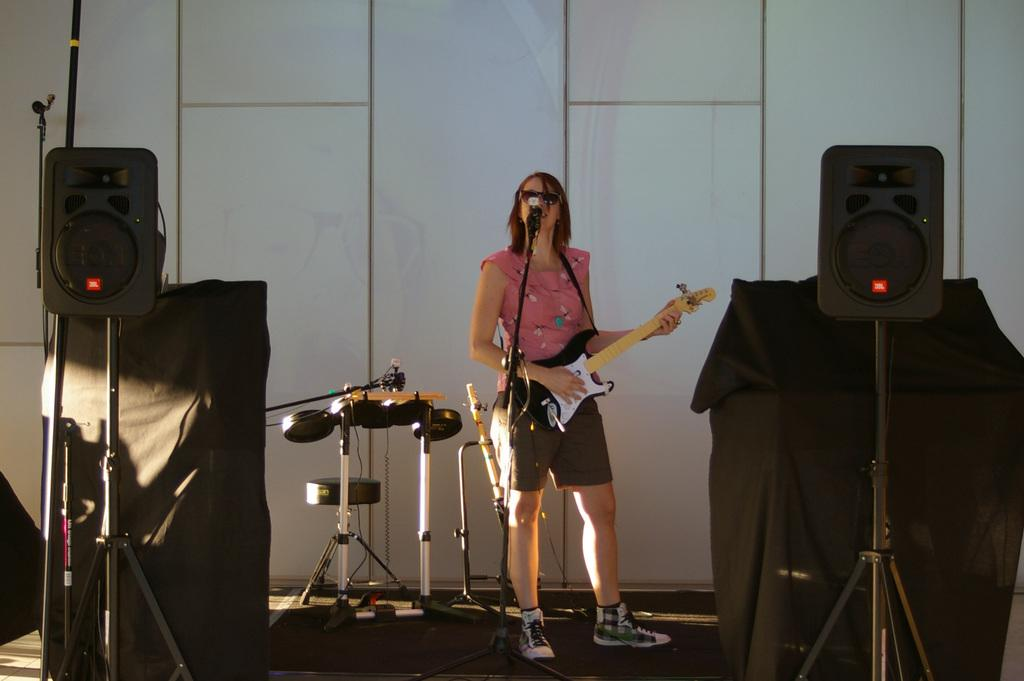Who is the main subject in the image? There is a woman in the image. What is the woman doing in the image? The woman is standing, playing a guitar, and singing on a microphone. What other objects related to music can be seen in the image? There are musical instruments and speakers in the image. What is visible in the background of the image? There is a wall in the background. What type of alarm can be heard going off in the image? There is no alarm present or audible in the image; it features a woman playing a guitar and singing on a microphone. What is the woman's chin doing while she is singing? The image does not provide information about the woman's chin while she is singing, as it focuses on her playing a guitar and singing on a microphone. 